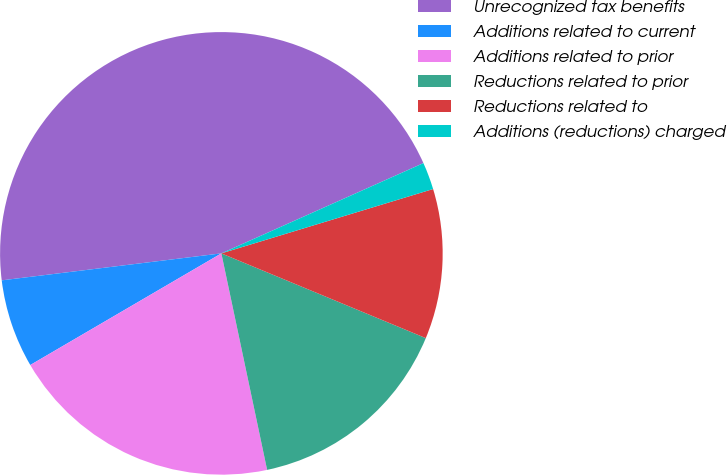Convert chart. <chart><loc_0><loc_0><loc_500><loc_500><pie_chart><fcel>Unrecognized tax benefits<fcel>Additions related to current<fcel>Additions related to prior<fcel>Reductions related to prior<fcel>Reductions related to<fcel>Additions (reductions) charged<nl><fcel>45.26%<fcel>6.47%<fcel>19.9%<fcel>15.43%<fcel>10.95%<fcel>1.99%<nl></chart> 